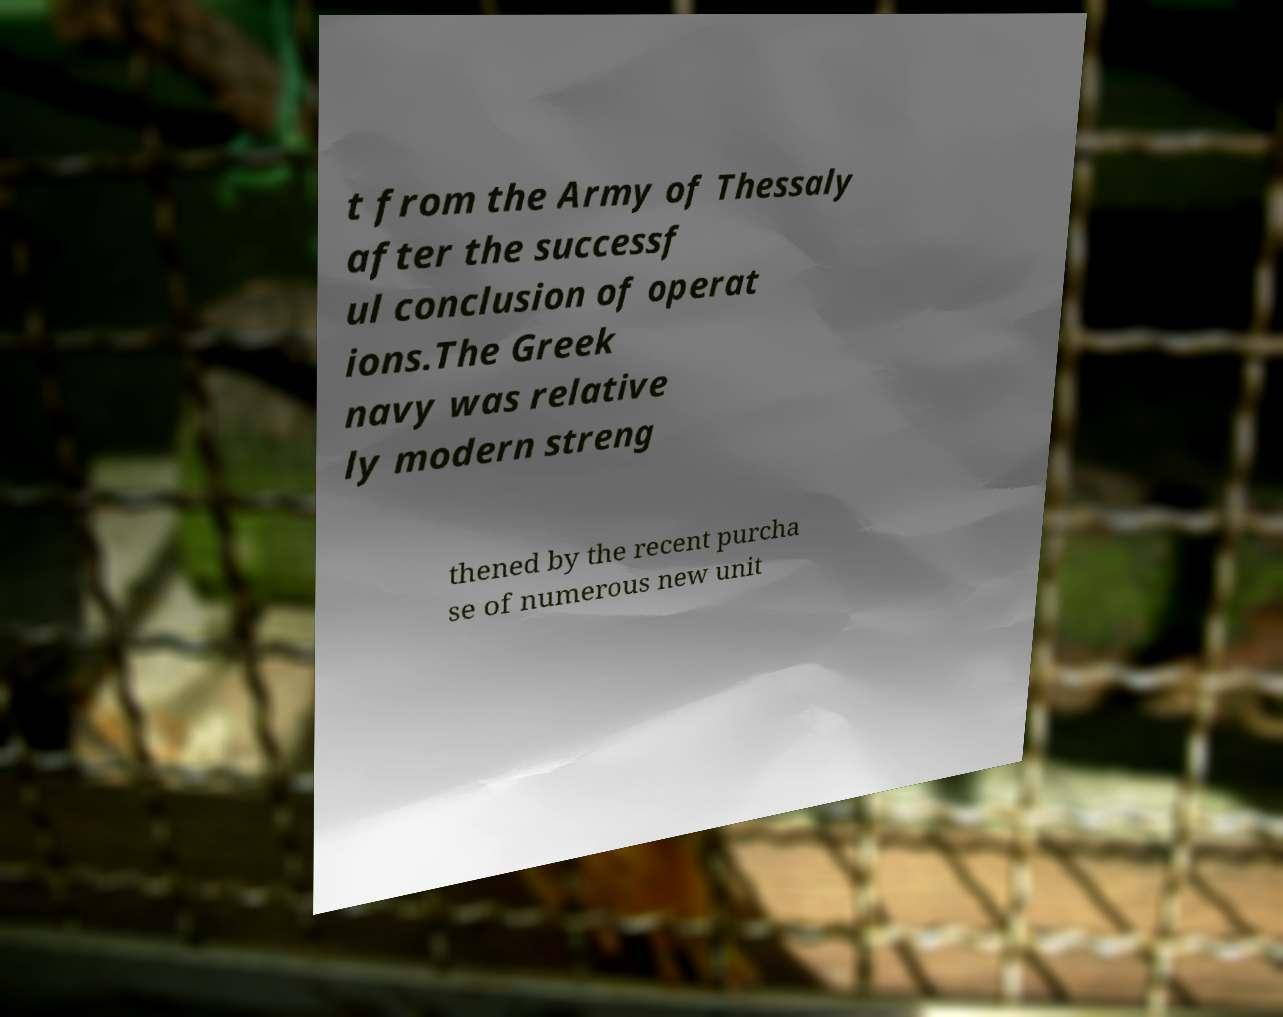There's text embedded in this image that I need extracted. Can you transcribe it verbatim? t from the Army of Thessaly after the successf ul conclusion of operat ions.The Greek navy was relative ly modern streng thened by the recent purcha se of numerous new unit 